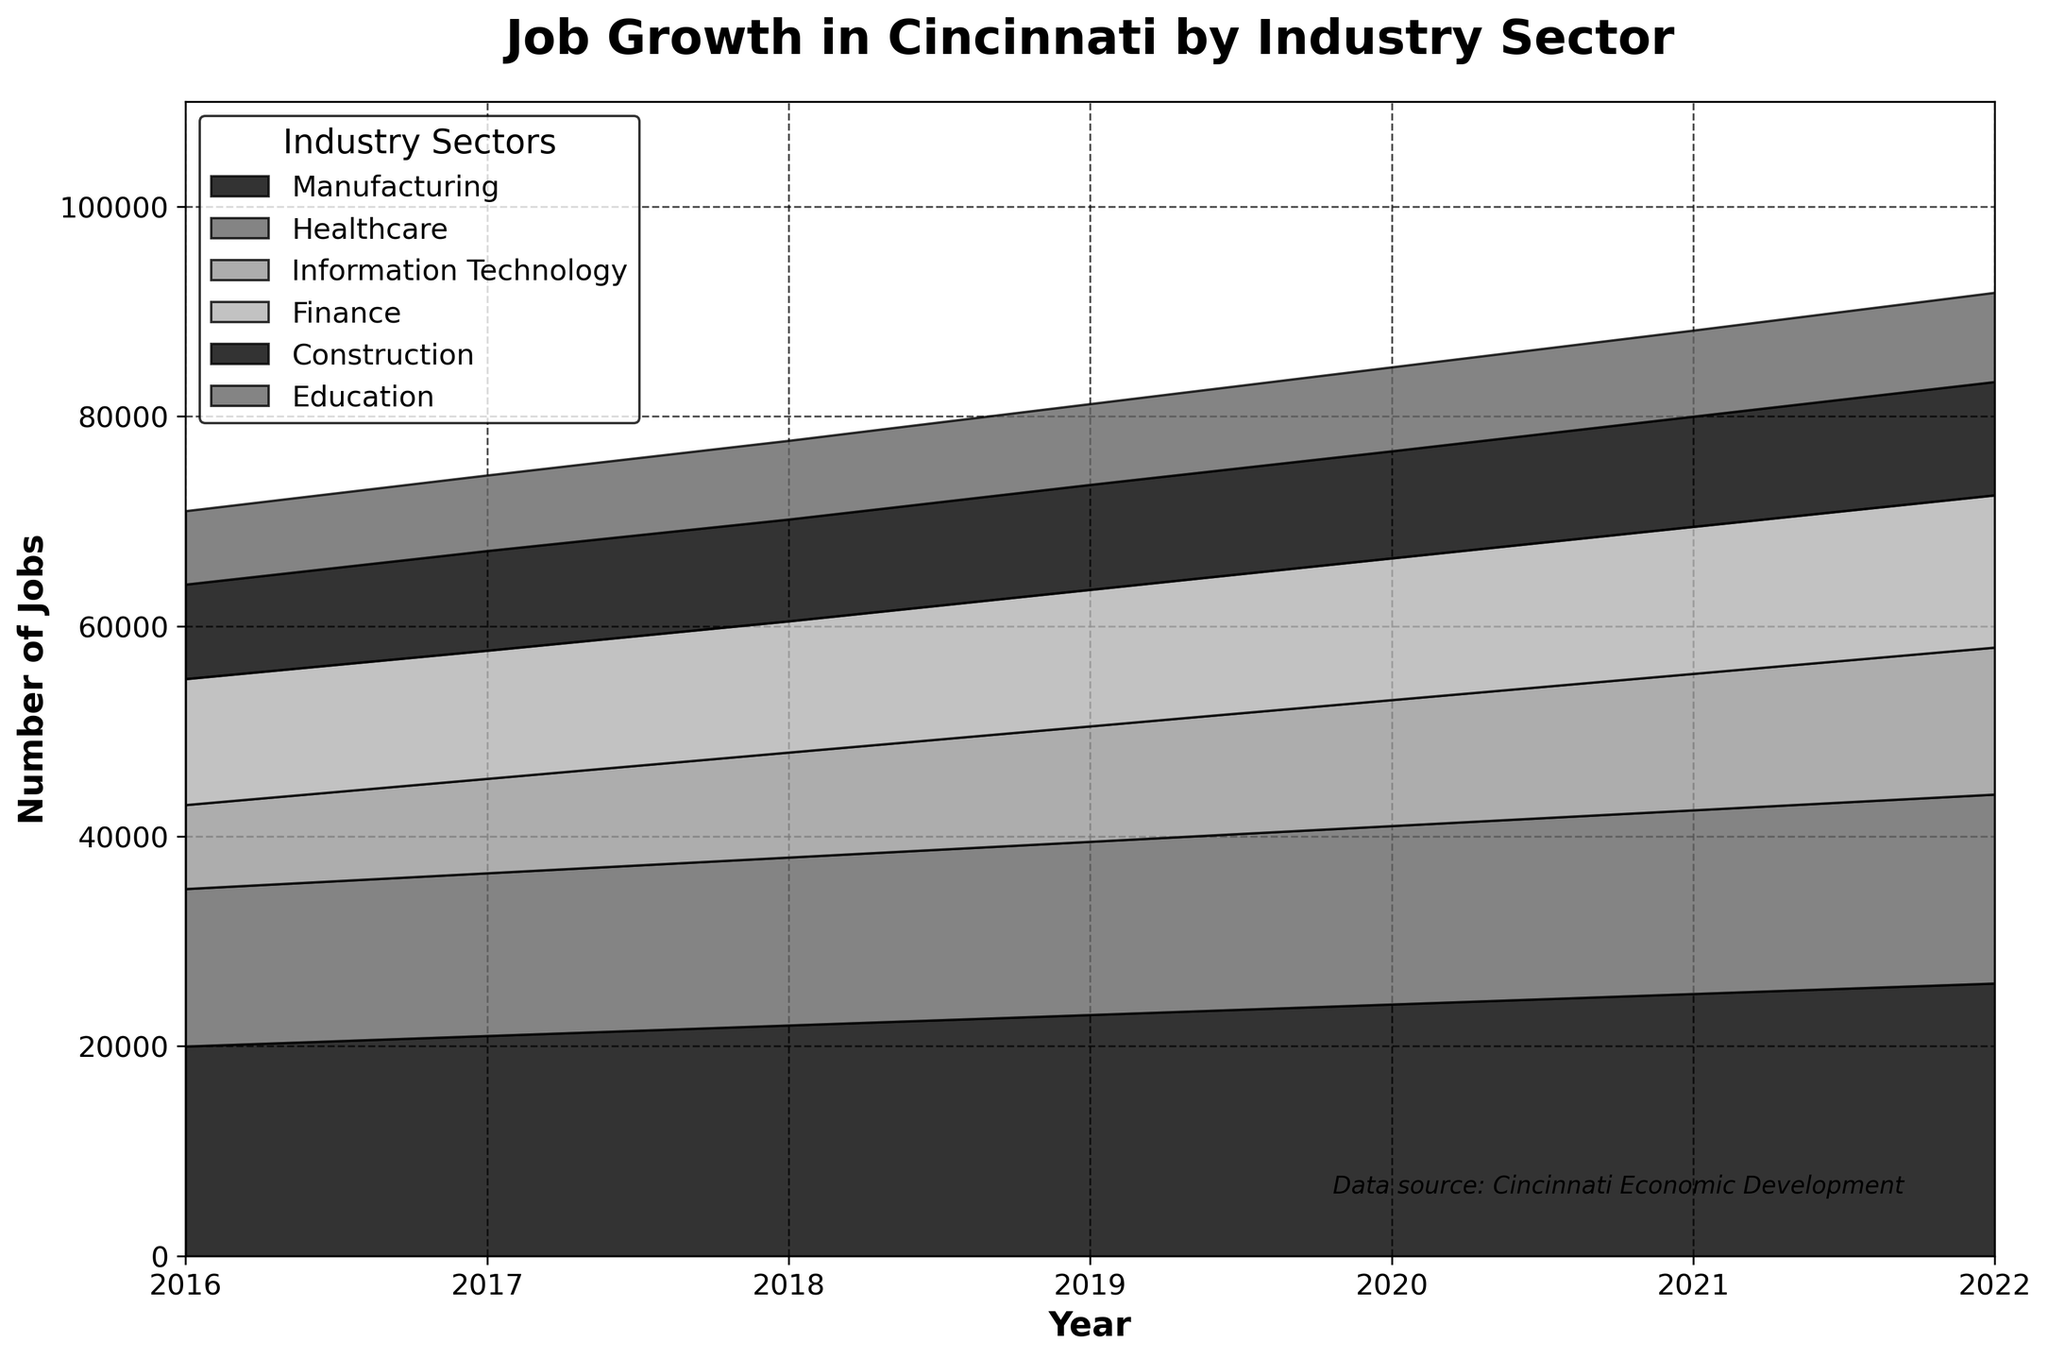What is the title of the chart? The title of the chart is displayed at the top of the figure. The text used in the title helps summarize the content of the figure.
Answer: Job Growth in Cincinnati by Industry Sector How many industry sectors are shown in the chart? To find the number of industry sectors, you can look at the labels in the legend or the stackplot sections in different colors.
Answer: Six Which industry sector had the highest number of jobs in 2022? To answer this, look at the top-most layer in the area chart for the year 2022. The highest section represents the industry sector with the most jobs.
Answer: Manufacturing How much did the number of Healthcare jobs increase from 2016 to 2022? Subtract the number of Healthcare jobs in 2016 from the number in 2022. Specifically, look at the height of the Healthcare layer in the respective years on the y-axis.
Answer: 3000 Which industry sector showed the least amount of growth from 2016 to 2022? Compare the difference in the number of jobs from 2016 to 2022 for each industry sector. The sector with the smallest difference is the answer.
Answer: Education By how much did the total number of jobs grow from 2016 to 2022? Sum the number of jobs for all sectors in both 2016 and 2022, and then find the difference between these sums.
Answer: 41000 In which year did the Information Technology sector surpass the 10,000 job mark? Identify the year when the Information Technology section of the area chart first reaches or crosses the 10,000 job level on the y-axis.
Answer: 2018 Which two industry sectors had the closest number of jobs in 2021? Compare the heights of the areas representing each industry sector for the year 2021. Look for the two sectors whose layers are closest to each other.
Answer: IT and Finance What is the total number of jobs across all sectors in 2020? Sum the number of jobs across all sectors for the year 2020.
Answer: 86900 